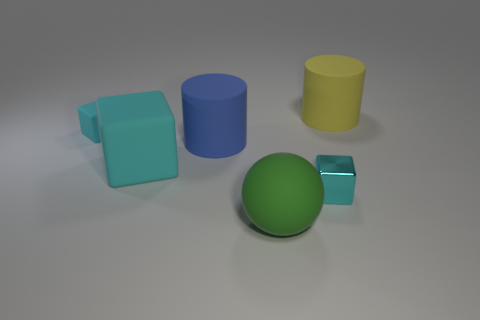What is the material of the big thing that is the same shape as the tiny cyan metal thing?
Provide a succinct answer. Rubber. Are there any other things of the same color as the large ball?
Make the answer very short. No. What number of things are either large yellow matte cylinders or small yellow balls?
Ensure brevity in your answer.  1. Do the matte cylinder that is behind the blue matte cylinder and the big matte cube have the same size?
Make the answer very short. Yes. How many other things are there of the same size as the green matte sphere?
Offer a very short reply. 3. Are any cyan metallic cubes visible?
Provide a succinct answer. Yes. There is a object right of the cyan object that is on the right side of the ball; what is its size?
Provide a succinct answer. Large. There is a object that is on the left side of the large cyan object; is it the same color as the large rubber cylinder in front of the big yellow rubber object?
Provide a short and direct response. No. What color is the thing that is both in front of the blue cylinder and left of the green matte thing?
Your answer should be very brief. Cyan. How many other objects are the same shape as the small cyan metallic thing?
Offer a terse response. 2. 